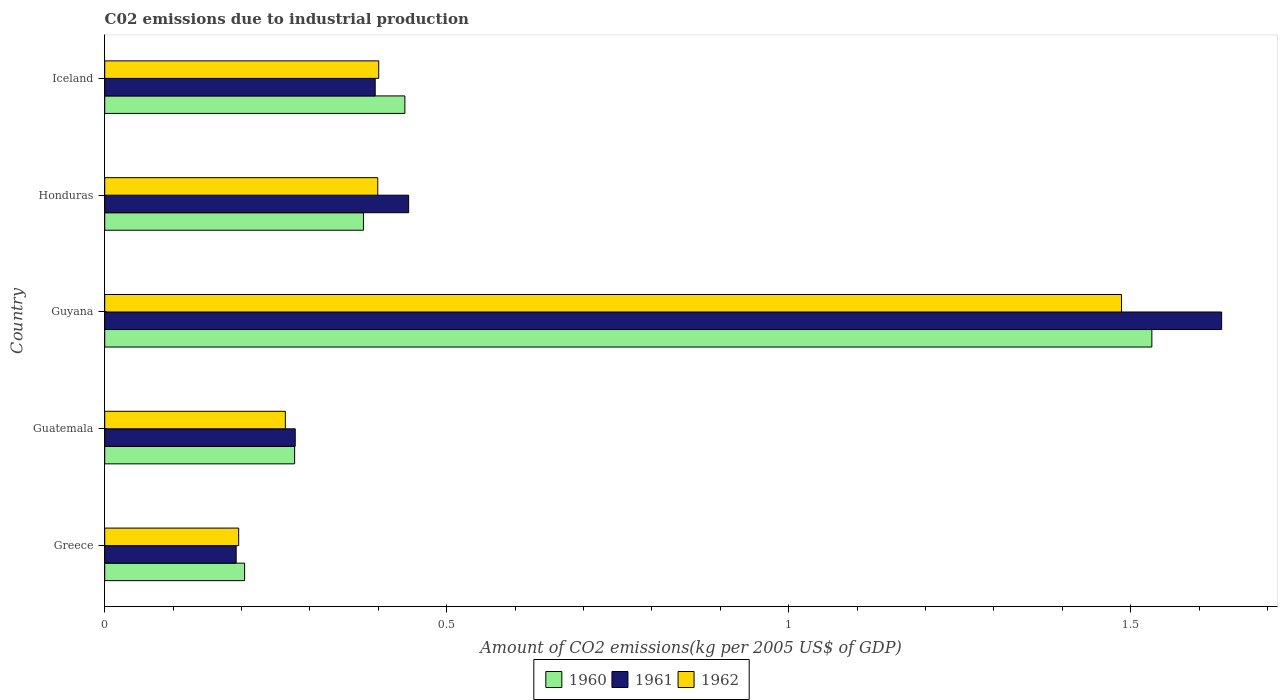How many different coloured bars are there?
Give a very brief answer. 3. How many groups of bars are there?
Keep it short and to the point. 5. Are the number of bars on each tick of the Y-axis equal?
Your answer should be very brief. Yes. How many bars are there on the 5th tick from the top?
Your answer should be very brief. 3. How many bars are there on the 2nd tick from the bottom?
Your answer should be very brief. 3. What is the label of the 1st group of bars from the top?
Ensure brevity in your answer.  Iceland. What is the amount of CO2 emitted due to industrial production in 1960 in Iceland?
Give a very brief answer. 0.44. Across all countries, what is the maximum amount of CO2 emitted due to industrial production in 1961?
Give a very brief answer. 1.63. Across all countries, what is the minimum amount of CO2 emitted due to industrial production in 1961?
Keep it short and to the point. 0.19. In which country was the amount of CO2 emitted due to industrial production in 1961 maximum?
Make the answer very short. Guyana. In which country was the amount of CO2 emitted due to industrial production in 1962 minimum?
Your response must be concise. Greece. What is the total amount of CO2 emitted due to industrial production in 1961 in the graph?
Make the answer very short. 2.94. What is the difference between the amount of CO2 emitted due to industrial production in 1960 in Guyana and that in Honduras?
Your response must be concise. 1.15. What is the difference between the amount of CO2 emitted due to industrial production in 1961 in Guatemala and the amount of CO2 emitted due to industrial production in 1962 in Honduras?
Ensure brevity in your answer.  -0.12. What is the average amount of CO2 emitted due to industrial production in 1961 per country?
Your answer should be compact. 0.59. What is the difference between the amount of CO2 emitted due to industrial production in 1960 and amount of CO2 emitted due to industrial production in 1962 in Greece?
Your response must be concise. 0.01. In how many countries, is the amount of CO2 emitted due to industrial production in 1961 greater than 0.30000000000000004 kg?
Ensure brevity in your answer.  3. What is the ratio of the amount of CO2 emitted due to industrial production in 1961 in Guyana to that in Iceland?
Your answer should be compact. 4.13. Is the difference between the amount of CO2 emitted due to industrial production in 1960 in Greece and Guatemala greater than the difference between the amount of CO2 emitted due to industrial production in 1962 in Greece and Guatemala?
Ensure brevity in your answer.  No. What is the difference between the highest and the second highest amount of CO2 emitted due to industrial production in 1960?
Your response must be concise. 1.09. What is the difference between the highest and the lowest amount of CO2 emitted due to industrial production in 1960?
Give a very brief answer. 1.33. In how many countries, is the amount of CO2 emitted due to industrial production in 1960 greater than the average amount of CO2 emitted due to industrial production in 1960 taken over all countries?
Ensure brevity in your answer.  1. Is the sum of the amount of CO2 emitted due to industrial production in 1960 in Guyana and Iceland greater than the maximum amount of CO2 emitted due to industrial production in 1961 across all countries?
Your answer should be compact. Yes. What does the 3rd bar from the bottom in Honduras represents?
Offer a terse response. 1962. How many countries are there in the graph?
Provide a short and direct response. 5. Does the graph contain any zero values?
Give a very brief answer. No. Does the graph contain grids?
Your answer should be very brief. No. Where does the legend appear in the graph?
Offer a very short reply. Bottom center. What is the title of the graph?
Your response must be concise. C02 emissions due to industrial production. Does "1977" appear as one of the legend labels in the graph?
Give a very brief answer. No. What is the label or title of the X-axis?
Make the answer very short. Amount of CO2 emissions(kg per 2005 US$ of GDP). What is the label or title of the Y-axis?
Your response must be concise. Country. What is the Amount of CO2 emissions(kg per 2005 US$ of GDP) of 1960 in Greece?
Keep it short and to the point. 0.2. What is the Amount of CO2 emissions(kg per 2005 US$ of GDP) in 1961 in Greece?
Ensure brevity in your answer.  0.19. What is the Amount of CO2 emissions(kg per 2005 US$ of GDP) in 1962 in Greece?
Offer a terse response. 0.2. What is the Amount of CO2 emissions(kg per 2005 US$ of GDP) in 1960 in Guatemala?
Provide a succinct answer. 0.28. What is the Amount of CO2 emissions(kg per 2005 US$ of GDP) in 1961 in Guatemala?
Ensure brevity in your answer.  0.28. What is the Amount of CO2 emissions(kg per 2005 US$ of GDP) of 1962 in Guatemala?
Your answer should be compact. 0.26. What is the Amount of CO2 emissions(kg per 2005 US$ of GDP) in 1960 in Guyana?
Provide a short and direct response. 1.53. What is the Amount of CO2 emissions(kg per 2005 US$ of GDP) in 1961 in Guyana?
Your answer should be compact. 1.63. What is the Amount of CO2 emissions(kg per 2005 US$ of GDP) in 1962 in Guyana?
Your answer should be compact. 1.49. What is the Amount of CO2 emissions(kg per 2005 US$ of GDP) in 1960 in Honduras?
Offer a terse response. 0.38. What is the Amount of CO2 emissions(kg per 2005 US$ of GDP) of 1961 in Honduras?
Your answer should be compact. 0.44. What is the Amount of CO2 emissions(kg per 2005 US$ of GDP) in 1962 in Honduras?
Give a very brief answer. 0.4. What is the Amount of CO2 emissions(kg per 2005 US$ of GDP) in 1960 in Iceland?
Your answer should be compact. 0.44. What is the Amount of CO2 emissions(kg per 2005 US$ of GDP) in 1961 in Iceland?
Ensure brevity in your answer.  0.4. What is the Amount of CO2 emissions(kg per 2005 US$ of GDP) of 1962 in Iceland?
Make the answer very short. 0.4. Across all countries, what is the maximum Amount of CO2 emissions(kg per 2005 US$ of GDP) in 1960?
Offer a very short reply. 1.53. Across all countries, what is the maximum Amount of CO2 emissions(kg per 2005 US$ of GDP) in 1961?
Your response must be concise. 1.63. Across all countries, what is the maximum Amount of CO2 emissions(kg per 2005 US$ of GDP) in 1962?
Offer a terse response. 1.49. Across all countries, what is the minimum Amount of CO2 emissions(kg per 2005 US$ of GDP) of 1960?
Offer a terse response. 0.2. Across all countries, what is the minimum Amount of CO2 emissions(kg per 2005 US$ of GDP) in 1961?
Your answer should be compact. 0.19. Across all countries, what is the minimum Amount of CO2 emissions(kg per 2005 US$ of GDP) of 1962?
Provide a succinct answer. 0.2. What is the total Amount of CO2 emissions(kg per 2005 US$ of GDP) of 1960 in the graph?
Ensure brevity in your answer.  2.83. What is the total Amount of CO2 emissions(kg per 2005 US$ of GDP) in 1961 in the graph?
Your response must be concise. 2.94. What is the total Amount of CO2 emissions(kg per 2005 US$ of GDP) of 1962 in the graph?
Keep it short and to the point. 2.75. What is the difference between the Amount of CO2 emissions(kg per 2005 US$ of GDP) of 1960 in Greece and that in Guatemala?
Give a very brief answer. -0.07. What is the difference between the Amount of CO2 emissions(kg per 2005 US$ of GDP) in 1961 in Greece and that in Guatemala?
Your response must be concise. -0.09. What is the difference between the Amount of CO2 emissions(kg per 2005 US$ of GDP) in 1962 in Greece and that in Guatemala?
Make the answer very short. -0.07. What is the difference between the Amount of CO2 emissions(kg per 2005 US$ of GDP) of 1960 in Greece and that in Guyana?
Ensure brevity in your answer.  -1.33. What is the difference between the Amount of CO2 emissions(kg per 2005 US$ of GDP) of 1961 in Greece and that in Guyana?
Your answer should be compact. -1.44. What is the difference between the Amount of CO2 emissions(kg per 2005 US$ of GDP) in 1962 in Greece and that in Guyana?
Provide a short and direct response. -1.29. What is the difference between the Amount of CO2 emissions(kg per 2005 US$ of GDP) in 1960 in Greece and that in Honduras?
Offer a terse response. -0.17. What is the difference between the Amount of CO2 emissions(kg per 2005 US$ of GDP) in 1961 in Greece and that in Honduras?
Offer a very short reply. -0.25. What is the difference between the Amount of CO2 emissions(kg per 2005 US$ of GDP) in 1962 in Greece and that in Honduras?
Keep it short and to the point. -0.2. What is the difference between the Amount of CO2 emissions(kg per 2005 US$ of GDP) in 1960 in Greece and that in Iceland?
Offer a terse response. -0.23. What is the difference between the Amount of CO2 emissions(kg per 2005 US$ of GDP) of 1961 in Greece and that in Iceland?
Keep it short and to the point. -0.2. What is the difference between the Amount of CO2 emissions(kg per 2005 US$ of GDP) of 1962 in Greece and that in Iceland?
Offer a terse response. -0.2. What is the difference between the Amount of CO2 emissions(kg per 2005 US$ of GDP) of 1960 in Guatemala and that in Guyana?
Provide a succinct answer. -1.25. What is the difference between the Amount of CO2 emissions(kg per 2005 US$ of GDP) in 1961 in Guatemala and that in Guyana?
Your response must be concise. -1.35. What is the difference between the Amount of CO2 emissions(kg per 2005 US$ of GDP) of 1962 in Guatemala and that in Guyana?
Your answer should be compact. -1.22. What is the difference between the Amount of CO2 emissions(kg per 2005 US$ of GDP) of 1960 in Guatemala and that in Honduras?
Offer a terse response. -0.1. What is the difference between the Amount of CO2 emissions(kg per 2005 US$ of GDP) in 1961 in Guatemala and that in Honduras?
Make the answer very short. -0.17. What is the difference between the Amount of CO2 emissions(kg per 2005 US$ of GDP) of 1962 in Guatemala and that in Honduras?
Your answer should be compact. -0.14. What is the difference between the Amount of CO2 emissions(kg per 2005 US$ of GDP) of 1960 in Guatemala and that in Iceland?
Keep it short and to the point. -0.16. What is the difference between the Amount of CO2 emissions(kg per 2005 US$ of GDP) in 1961 in Guatemala and that in Iceland?
Keep it short and to the point. -0.12. What is the difference between the Amount of CO2 emissions(kg per 2005 US$ of GDP) of 1962 in Guatemala and that in Iceland?
Give a very brief answer. -0.14. What is the difference between the Amount of CO2 emissions(kg per 2005 US$ of GDP) in 1960 in Guyana and that in Honduras?
Offer a terse response. 1.15. What is the difference between the Amount of CO2 emissions(kg per 2005 US$ of GDP) in 1961 in Guyana and that in Honduras?
Keep it short and to the point. 1.19. What is the difference between the Amount of CO2 emissions(kg per 2005 US$ of GDP) in 1962 in Guyana and that in Honduras?
Ensure brevity in your answer.  1.09. What is the difference between the Amount of CO2 emissions(kg per 2005 US$ of GDP) in 1960 in Guyana and that in Iceland?
Provide a short and direct response. 1.09. What is the difference between the Amount of CO2 emissions(kg per 2005 US$ of GDP) of 1961 in Guyana and that in Iceland?
Make the answer very short. 1.24. What is the difference between the Amount of CO2 emissions(kg per 2005 US$ of GDP) in 1962 in Guyana and that in Iceland?
Provide a succinct answer. 1.09. What is the difference between the Amount of CO2 emissions(kg per 2005 US$ of GDP) in 1960 in Honduras and that in Iceland?
Ensure brevity in your answer.  -0.06. What is the difference between the Amount of CO2 emissions(kg per 2005 US$ of GDP) of 1961 in Honduras and that in Iceland?
Keep it short and to the point. 0.05. What is the difference between the Amount of CO2 emissions(kg per 2005 US$ of GDP) of 1962 in Honduras and that in Iceland?
Provide a succinct answer. -0. What is the difference between the Amount of CO2 emissions(kg per 2005 US$ of GDP) of 1960 in Greece and the Amount of CO2 emissions(kg per 2005 US$ of GDP) of 1961 in Guatemala?
Your answer should be compact. -0.07. What is the difference between the Amount of CO2 emissions(kg per 2005 US$ of GDP) of 1960 in Greece and the Amount of CO2 emissions(kg per 2005 US$ of GDP) of 1962 in Guatemala?
Provide a short and direct response. -0.06. What is the difference between the Amount of CO2 emissions(kg per 2005 US$ of GDP) of 1961 in Greece and the Amount of CO2 emissions(kg per 2005 US$ of GDP) of 1962 in Guatemala?
Provide a succinct answer. -0.07. What is the difference between the Amount of CO2 emissions(kg per 2005 US$ of GDP) of 1960 in Greece and the Amount of CO2 emissions(kg per 2005 US$ of GDP) of 1961 in Guyana?
Offer a terse response. -1.43. What is the difference between the Amount of CO2 emissions(kg per 2005 US$ of GDP) in 1960 in Greece and the Amount of CO2 emissions(kg per 2005 US$ of GDP) in 1962 in Guyana?
Your response must be concise. -1.28. What is the difference between the Amount of CO2 emissions(kg per 2005 US$ of GDP) of 1961 in Greece and the Amount of CO2 emissions(kg per 2005 US$ of GDP) of 1962 in Guyana?
Your response must be concise. -1.29. What is the difference between the Amount of CO2 emissions(kg per 2005 US$ of GDP) in 1960 in Greece and the Amount of CO2 emissions(kg per 2005 US$ of GDP) in 1961 in Honduras?
Your answer should be very brief. -0.24. What is the difference between the Amount of CO2 emissions(kg per 2005 US$ of GDP) in 1960 in Greece and the Amount of CO2 emissions(kg per 2005 US$ of GDP) in 1962 in Honduras?
Provide a short and direct response. -0.19. What is the difference between the Amount of CO2 emissions(kg per 2005 US$ of GDP) of 1961 in Greece and the Amount of CO2 emissions(kg per 2005 US$ of GDP) of 1962 in Honduras?
Your response must be concise. -0.21. What is the difference between the Amount of CO2 emissions(kg per 2005 US$ of GDP) in 1960 in Greece and the Amount of CO2 emissions(kg per 2005 US$ of GDP) in 1961 in Iceland?
Keep it short and to the point. -0.19. What is the difference between the Amount of CO2 emissions(kg per 2005 US$ of GDP) in 1960 in Greece and the Amount of CO2 emissions(kg per 2005 US$ of GDP) in 1962 in Iceland?
Your answer should be compact. -0.2. What is the difference between the Amount of CO2 emissions(kg per 2005 US$ of GDP) in 1961 in Greece and the Amount of CO2 emissions(kg per 2005 US$ of GDP) in 1962 in Iceland?
Give a very brief answer. -0.21. What is the difference between the Amount of CO2 emissions(kg per 2005 US$ of GDP) of 1960 in Guatemala and the Amount of CO2 emissions(kg per 2005 US$ of GDP) of 1961 in Guyana?
Give a very brief answer. -1.36. What is the difference between the Amount of CO2 emissions(kg per 2005 US$ of GDP) of 1960 in Guatemala and the Amount of CO2 emissions(kg per 2005 US$ of GDP) of 1962 in Guyana?
Provide a succinct answer. -1.21. What is the difference between the Amount of CO2 emissions(kg per 2005 US$ of GDP) in 1961 in Guatemala and the Amount of CO2 emissions(kg per 2005 US$ of GDP) in 1962 in Guyana?
Give a very brief answer. -1.21. What is the difference between the Amount of CO2 emissions(kg per 2005 US$ of GDP) of 1960 in Guatemala and the Amount of CO2 emissions(kg per 2005 US$ of GDP) of 1961 in Honduras?
Provide a short and direct response. -0.17. What is the difference between the Amount of CO2 emissions(kg per 2005 US$ of GDP) in 1960 in Guatemala and the Amount of CO2 emissions(kg per 2005 US$ of GDP) in 1962 in Honduras?
Give a very brief answer. -0.12. What is the difference between the Amount of CO2 emissions(kg per 2005 US$ of GDP) of 1961 in Guatemala and the Amount of CO2 emissions(kg per 2005 US$ of GDP) of 1962 in Honduras?
Your answer should be compact. -0.12. What is the difference between the Amount of CO2 emissions(kg per 2005 US$ of GDP) in 1960 in Guatemala and the Amount of CO2 emissions(kg per 2005 US$ of GDP) in 1961 in Iceland?
Keep it short and to the point. -0.12. What is the difference between the Amount of CO2 emissions(kg per 2005 US$ of GDP) of 1960 in Guatemala and the Amount of CO2 emissions(kg per 2005 US$ of GDP) of 1962 in Iceland?
Give a very brief answer. -0.12. What is the difference between the Amount of CO2 emissions(kg per 2005 US$ of GDP) of 1961 in Guatemala and the Amount of CO2 emissions(kg per 2005 US$ of GDP) of 1962 in Iceland?
Give a very brief answer. -0.12. What is the difference between the Amount of CO2 emissions(kg per 2005 US$ of GDP) in 1960 in Guyana and the Amount of CO2 emissions(kg per 2005 US$ of GDP) in 1961 in Honduras?
Your answer should be compact. 1.09. What is the difference between the Amount of CO2 emissions(kg per 2005 US$ of GDP) of 1960 in Guyana and the Amount of CO2 emissions(kg per 2005 US$ of GDP) of 1962 in Honduras?
Offer a very short reply. 1.13. What is the difference between the Amount of CO2 emissions(kg per 2005 US$ of GDP) of 1961 in Guyana and the Amount of CO2 emissions(kg per 2005 US$ of GDP) of 1962 in Honduras?
Your answer should be compact. 1.23. What is the difference between the Amount of CO2 emissions(kg per 2005 US$ of GDP) in 1960 in Guyana and the Amount of CO2 emissions(kg per 2005 US$ of GDP) in 1961 in Iceland?
Your answer should be very brief. 1.14. What is the difference between the Amount of CO2 emissions(kg per 2005 US$ of GDP) in 1960 in Guyana and the Amount of CO2 emissions(kg per 2005 US$ of GDP) in 1962 in Iceland?
Your response must be concise. 1.13. What is the difference between the Amount of CO2 emissions(kg per 2005 US$ of GDP) in 1961 in Guyana and the Amount of CO2 emissions(kg per 2005 US$ of GDP) in 1962 in Iceland?
Make the answer very short. 1.23. What is the difference between the Amount of CO2 emissions(kg per 2005 US$ of GDP) in 1960 in Honduras and the Amount of CO2 emissions(kg per 2005 US$ of GDP) in 1961 in Iceland?
Your response must be concise. -0.02. What is the difference between the Amount of CO2 emissions(kg per 2005 US$ of GDP) in 1960 in Honduras and the Amount of CO2 emissions(kg per 2005 US$ of GDP) in 1962 in Iceland?
Offer a very short reply. -0.02. What is the difference between the Amount of CO2 emissions(kg per 2005 US$ of GDP) in 1961 in Honduras and the Amount of CO2 emissions(kg per 2005 US$ of GDP) in 1962 in Iceland?
Your answer should be very brief. 0.04. What is the average Amount of CO2 emissions(kg per 2005 US$ of GDP) of 1960 per country?
Offer a very short reply. 0.57. What is the average Amount of CO2 emissions(kg per 2005 US$ of GDP) of 1961 per country?
Keep it short and to the point. 0.59. What is the average Amount of CO2 emissions(kg per 2005 US$ of GDP) in 1962 per country?
Make the answer very short. 0.55. What is the difference between the Amount of CO2 emissions(kg per 2005 US$ of GDP) of 1960 and Amount of CO2 emissions(kg per 2005 US$ of GDP) of 1961 in Greece?
Provide a succinct answer. 0.01. What is the difference between the Amount of CO2 emissions(kg per 2005 US$ of GDP) of 1960 and Amount of CO2 emissions(kg per 2005 US$ of GDP) of 1962 in Greece?
Give a very brief answer. 0.01. What is the difference between the Amount of CO2 emissions(kg per 2005 US$ of GDP) in 1961 and Amount of CO2 emissions(kg per 2005 US$ of GDP) in 1962 in Greece?
Your response must be concise. -0. What is the difference between the Amount of CO2 emissions(kg per 2005 US$ of GDP) in 1960 and Amount of CO2 emissions(kg per 2005 US$ of GDP) in 1961 in Guatemala?
Give a very brief answer. -0. What is the difference between the Amount of CO2 emissions(kg per 2005 US$ of GDP) in 1960 and Amount of CO2 emissions(kg per 2005 US$ of GDP) in 1962 in Guatemala?
Your answer should be very brief. 0.01. What is the difference between the Amount of CO2 emissions(kg per 2005 US$ of GDP) in 1961 and Amount of CO2 emissions(kg per 2005 US$ of GDP) in 1962 in Guatemala?
Offer a very short reply. 0.01. What is the difference between the Amount of CO2 emissions(kg per 2005 US$ of GDP) of 1960 and Amount of CO2 emissions(kg per 2005 US$ of GDP) of 1961 in Guyana?
Your response must be concise. -0.1. What is the difference between the Amount of CO2 emissions(kg per 2005 US$ of GDP) in 1960 and Amount of CO2 emissions(kg per 2005 US$ of GDP) in 1962 in Guyana?
Provide a succinct answer. 0.04. What is the difference between the Amount of CO2 emissions(kg per 2005 US$ of GDP) of 1961 and Amount of CO2 emissions(kg per 2005 US$ of GDP) of 1962 in Guyana?
Make the answer very short. 0.15. What is the difference between the Amount of CO2 emissions(kg per 2005 US$ of GDP) in 1960 and Amount of CO2 emissions(kg per 2005 US$ of GDP) in 1961 in Honduras?
Offer a very short reply. -0.07. What is the difference between the Amount of CO2 emissions(kg per 2005 US$ of GDP) of 1960 and Amount of CO2 emissions(kg per 2005 US$ of GDP) of 1962 in Honduras?
Make the answer very short. -0.02. What is the difference between the Amount of CO2 emissions(kg per 2005 US$ of GDP) of 1961 and Amount of CO2 emissions(kg per 2005 US$ of GDP) of 1962 in Honduras?
Your answer should be very brief. 0.05. What is the difference between the Amount of CO2 emissions(kg per 2005 US$ of GDP) in 1960 and Amount of CO2 emissions(kg per 2005 US$ of GDP) in 1961 in Iceland?
Your answer should be very brief. 0.04. What is the difference between the Amount of CO2 emissions(kg per 2005 US$ of GDP) in 1960 and Amount of CO2 emissions(kg per 2005 US$ of GDP) in 1962 in Iceland?
Keep it short and to the point. 0.04. What is the difference between the Amount of CO2 emissions(kg per 2005 US$ of GDP) in 1961 and Amount of CO2 emissions(kg per 2005 US$ of GDP) in 1962 in Iceland?
Provide a short and direct response. -0.01. What is the ratio of the Amount of CO2 emissions(kg per 2005 US$ of GDP) in 1960 in Greece to that in Guatemala?
Your answer should be compact. 0.74. What is the ratio of the Amount of CO2 emissions(kg per 2005 US$ of GDP) in 1961 in Greece to that in Guatemala?
Ensure brevity in your answer.  0.69. What is the ratio of the Amount of CO2 emissions(kg per 2005 US$ of GDP) of 1962 in Greece to that in Guatemala?
Make the answer very short. 0.74. What is the ratio of the Amount of CO2 emissions(kg per 2005 US$ of GDP) of 1960 in Greece to that in Guyana?
Make the answer very short. 0.13. What is the ratio of the Amount of CO2 emissions(kg per 2005 US$ of GDP) of 1961 in Greece to that in Guyana?
Keep it short and to the point. 0.12. What is the ratio of the Amount of CO2 emissions(kg per 2005 US$ of GDP) in 1962 in Greece to that in Guyana?
Offer a very short reply. 0.13. What is the ratio of the Amount of CO2 emissions(kg per 2005 US$ of GDP) in 1960 in Greece to that in Honduras?
Give a very brief answer. 0.54. What is the ratio of the Amount of CO2 emissions(kg per 2005 US$ of GDP) of 1961 in Greece to that in Honduras?
Provide a succinct answer. 0.43. What is the ratio of the Amount of CO2 emissions(kg per 2005 US$ of GDP) of 1962 in Greece to that in Honduras?
Make the answer very short. 0.49. What is the ratio of the Amount of CO2 emissions(kg per 2005 US$ of GDP) in 1960 in Greece to that in Iceland?
Make the answer very short. 0.47. What is the ratio of the Amount of CO2 emissions(kg per 2005 US$ of GDP) in 1961 in Greece to that in Iceland?
Offer a very short reply. 0.49. What is the ratio of the Amount of CO2 emissions(kg per 2005 US$ of GDP) of 1962 in Greece to that in Iceland?
Make the answer very short. 0.49. What is the ratio of the Amount of CO2 emissions(kg per 2005 US$ of GDP) of 1960 in Guatemala to that in Guyana?
Provide a succinct answer. 0.18. What is the ratio of the Amount of CO2 emissions(kg per 2005 US$ of GDP) of 1961 in Guatemala to that in Guyana?
Your answer should be compact. 0.17. What is the ratio of the Amount of CO2 emissions(kg per 2005 US$ of GDP) in 1962 in Guatemala to that in Guyana?
Offer a terse response. 0.18. What is the ratio of the Amount of CO2 emissions(kg per 2005 US$ of GDP) of 1960 in Guatemala to that in Honduras?
Your response must be concise. 0.73. What is the ratio of the Amount of CO2 emissions(kg per 2005 US$ of GDP) of 1961 in Guatemala to that in Honduras?
Provide a short and direct response. 0.63. What is the ratio of the Amount of CO2 emissions(kg per 2005 US$ of GDP) in 1962 in Guatemala to that in Honduras?
Give a very brief answer. 0.66. What is the ratio of the Amount of CO2 emissions(kg per 2005 US$ of GDP) of 1960 in Guatemala to that in Iceland?
Your answer should be very brief. 0.63. What is the ratio of the Amount of CO2 emissions(kg per 2005 US$ of GDP) in 1961 in Guatemala to that in Iceland?
Keep it short and to the point. 0.7. What is the ratio of the Amount of CO2 emissions(kg per 2005 US$ of GDP) of 1962 in Guatemala to that in Iceland?
Provide a succinct answer. 0.66. What is the ratio of the Amount of CO2 emissions(kg per 2005 US$ of GDP) of 1960 in Guyana to that in Honduras?
Keep it short and to the point. 4.05. What is the ratio of the Amount of CO2 emissions(kg per 2005 US$ of GDP) of 1961 in Guyana to that in Honduras?
Your answer should be very brief. 3.68. What is the ratio of the Amount of CO2 emissions(kg per 2005 US$ of GDP) of 1962 in Guyana to that in Honduras?
Offer a very short reply. 3.72. What is the ratio of the Amount of CO2 emissions(kg per 2005 US$ of GDP) of 1960 in Guyana to that in Iceland?
Provide a short and direct response. 3.49. What is the ratio of the Amount of CO2 emissions(kg per 2005 US$ of GDP) in 1961 in Guyana to that in Iceland?
Make the answer very short. 4.13. What is the ratio of the Amount of CO2 emissions(kg per 2005 US$ of GDP) of 1962 in Guyana to that in Iceland?
Your answer should be very brief. 3.71. What is the ratio of the Amount of CO2 emissions(kg per 2005 US$ of GDP) in 1960 in Honduras to that in Iceland?
Offer a very short reply. 0.86. What is the ratio of the Amount of CO2 emissions(kg per 2005 US$ of GDP) in 1961 in Honduras to that in Iceland?
Your response must be concise. 1.12. What is the difference between the highest and the second highest Amount of CO2 emissions(kg per 2005 US$ of GDP) of 1960?
Offer a very short reply. 1.09. What is the difference between the highest and the second highest Amount of CO2 emissions(kg per 2005 US$ of GDP) in 1961?
Give a very brief answer. 1.19. What is the difference between the highest and the second highest Amount of CO2 emissions(kg per 2005 US$ of GDP) of 1962?
Ensure brevity in your answer.  1.09. What is the difference between the highest and the lowest Amount of CO2 emissions(kg per 2005 US$ of GDP) in 1960?
Ensure brevity in your answer.  1.33. What is the difference between the highest and the lowest Amount of CO2 emissions(kg per 2005 US$ of GDP) in 1961?
Your answer should be compact. 1.44. What is the difference between the highest and the lowest Amount of CO2 emissions(kg per 2005 US$ of GDP) in 1962?
Ensure brevity in your answer.  1.29. 